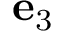<formula> <loc_0><loc_0><loc_500><loc_500>{ e } _ { 3 }</formula> 